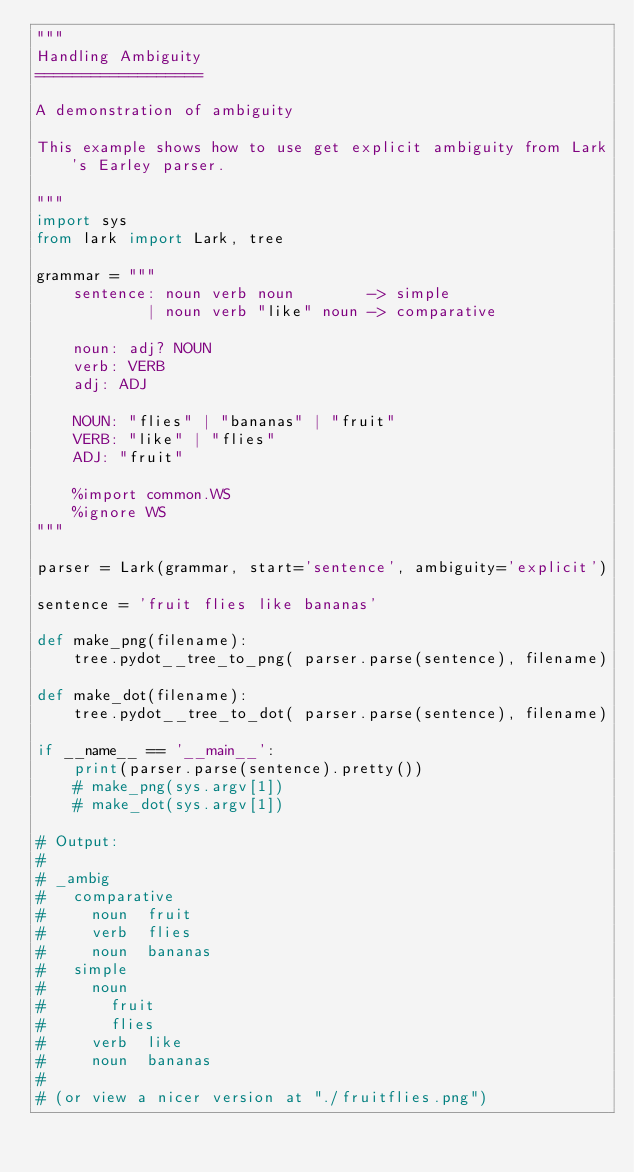Convert code to text. <code><loc_0><loc_0><loc_500><loc_500><_Python_>"""
Handling Ambiguity
==================

A demonstration of ambiguity

This example shows how to use get explicit ambiguity from Lark's Earley parser.

"""
import sys
from lark import Lark, tree

grammar = """
    sentence: noun verb noun        -> simple
            | noun verb "like" noun -> comparative

    noun: adj? NOUN
    verb: VERB
    adj: ADJ

    NOUN: "flies" | "bananas" | "fruit"
    VERB: "like" | "flies"
    ADJ: "fruit"

    %import common.WS
    %ignore WS
"""

parser = Lark(grammar, start='sentence', ambiguity='explicit')

sentence = 'fruit flies like bananas'

def make_png(filename):
    tree.pydot__tree_to_png( parser.parse(sentence), filename)

def make_dot(filename):
    tree.pydot__tree_to_dot( parser.parse(sentence), filename)

if __name__ == '__main__':
    print(parser.parse(sentence).pretty())
    # make_png(sys.argv[1])
    # make_dot(sys.argv[1])

# Output:
#
# _ambig
#   comparative
#     noun	fruit
#     verb	flies
#     noun	bananas
#   simple
#     noun
#       fruit
#       flies
#     verb	like
#     noun	bananas
#
# (or view a nicer version at "./fruitflies.png")
</code> 